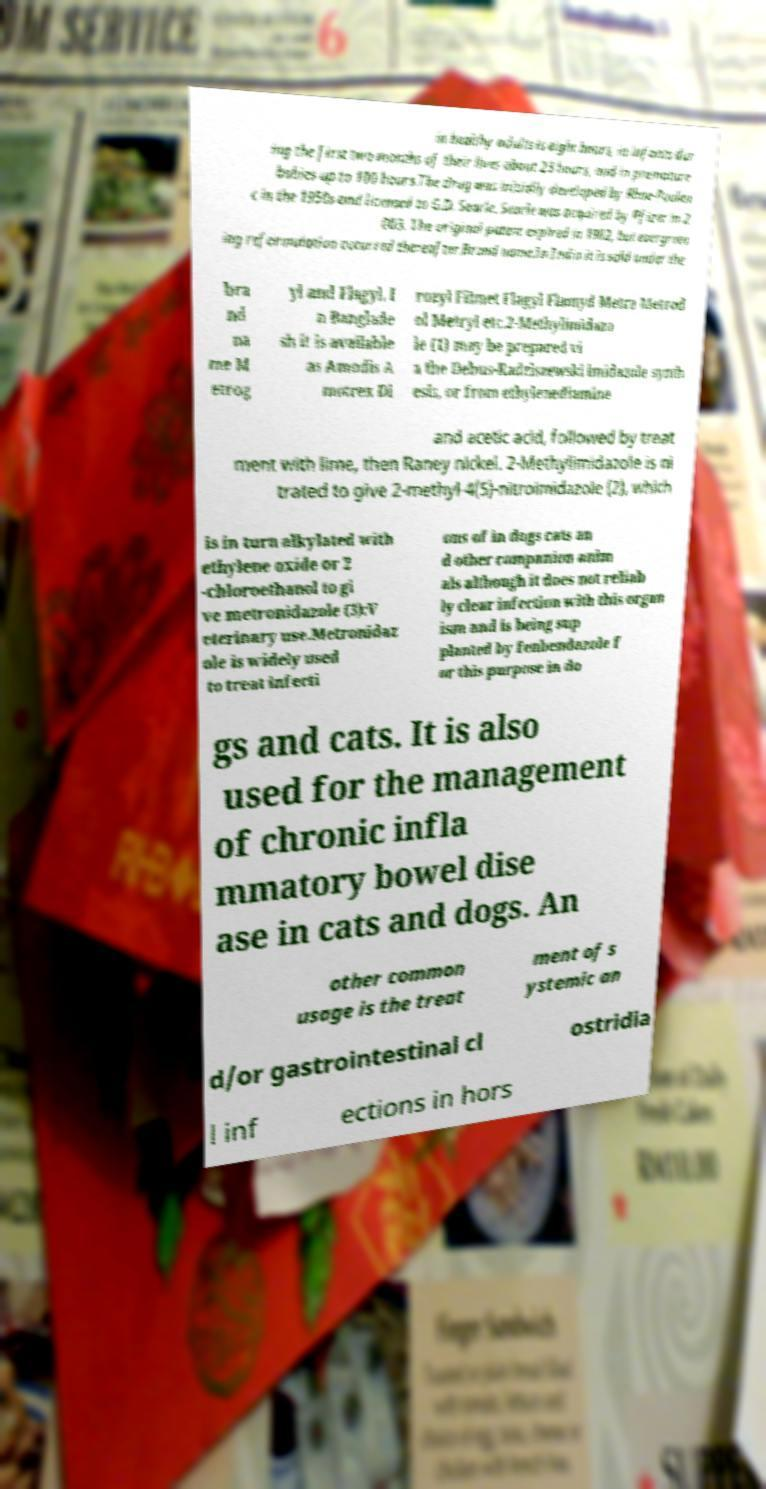Can you read and provide the text displayed in the image?This photo seems to have some interesting text. Can you extract and type it out for me? in healthy adults is eight hours, in infants dur ing the first two months of their lives about 23 hours, and in premature babies up to 100 hours.The drug was initially developed by Rhne-Poulen c in the 1950s and licensed to G.D. Searle. Searle was acquired by Pfizer in 2 003. The original patent expired in 1982, but evergreen ing reformulation occurred thereafter.Brand name.In India it is sold under the bra nd na me M etrog yl and Flagyl. I n Banglade sh it is available as Amodis A motrex Di rozyl Filmet Flagyl Flamyd Metra Metrod ol Metryl etc.2-Methylimidazo le (1) may be prepared vi a the Debus-Radziszewski imidazole synth esis, or from ethylenediamine and acetic acid, followed by treat ment with lime, then Raney nickel. 2-Methylimidazole is ni trated to give 2-methyl-4(5)-nitroimidazole (2), which is in turn alkylated with ethylene oxide or 2 -chloroethanol to gi ve metronidazole (3):V eterinary use.Metronidaz ole is widely used to treat infecti ons of in dogs cats an d other companion anim als although it does not reliab ly clear infection with this organ ism and is being sup planted by fenbendazole f or this purpose in do gs and cats. It is also used for the management of chronic infla mmatory bowel dise ase in cats and dogs. An other common usage is the treat ment of s ystemic an d/or gastrointestinal cl ostridia l inf ections in hors 